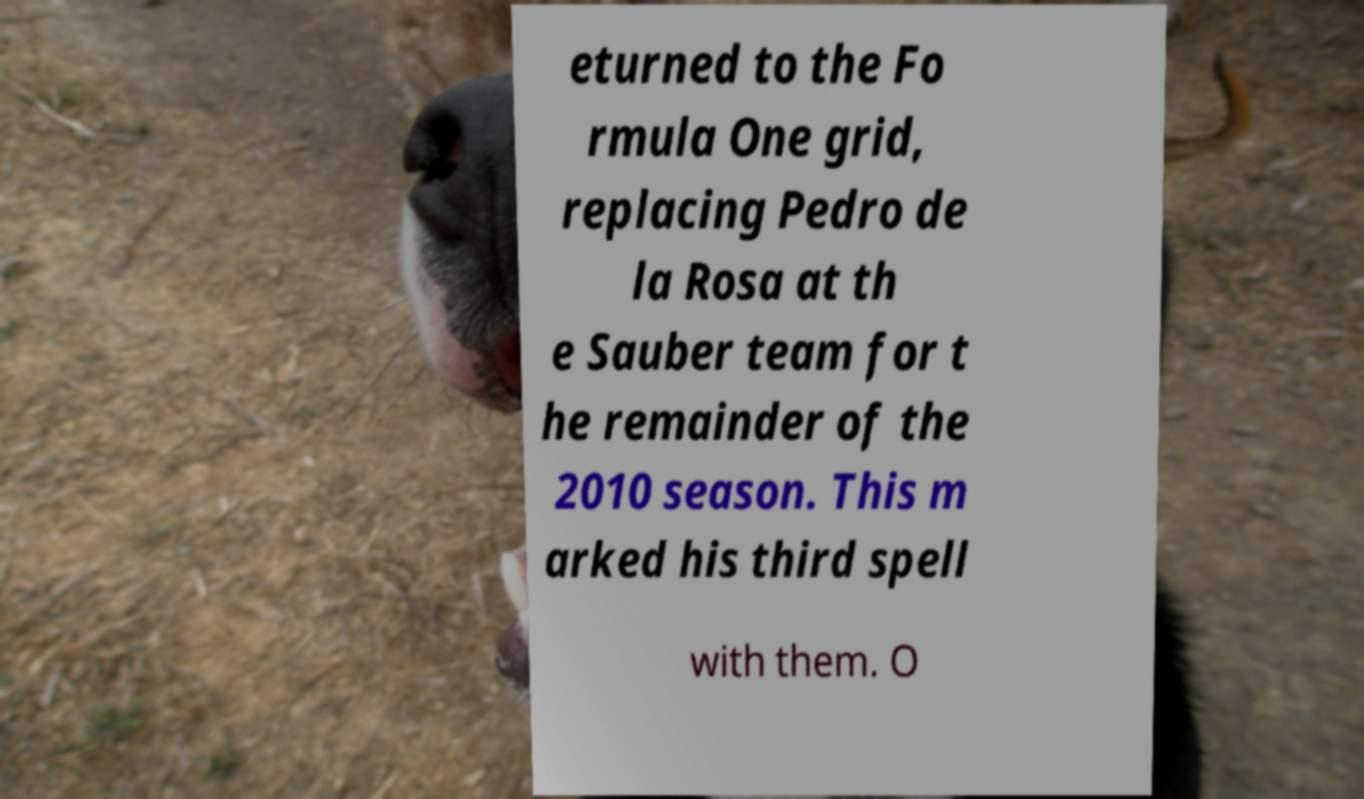Please read and relay the text visible in this image. What does it say? eturned to the Fo rmula One grid, replacing Pedro de la Rosa at th e Sauber team for t he remainder of the 2010 season. This m arked his third spell with them. O 